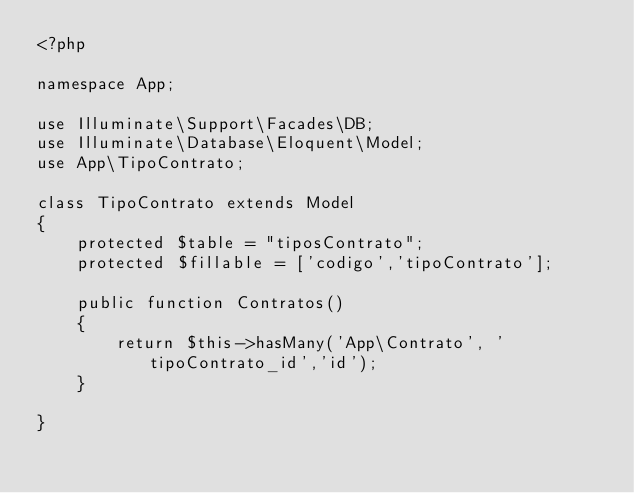<code> <loc_0><loc_0><loc_500><loc_500><_PHP_><?php

namespace App;

use Illuminate\Support\Facades\DB;
use Illuminate\Database\Eloquent\Model;
use App\TipoContrato;

class TipoContrato extends Model
{
	protected $table = "tiposContrato";
	protected $fillable = ['codigo','tipoContrato'];

	public function Contratos()
	{
		return $this->hasMany('App\Contrato', 'tipoContrato_id','id');
	}

}
</code> 